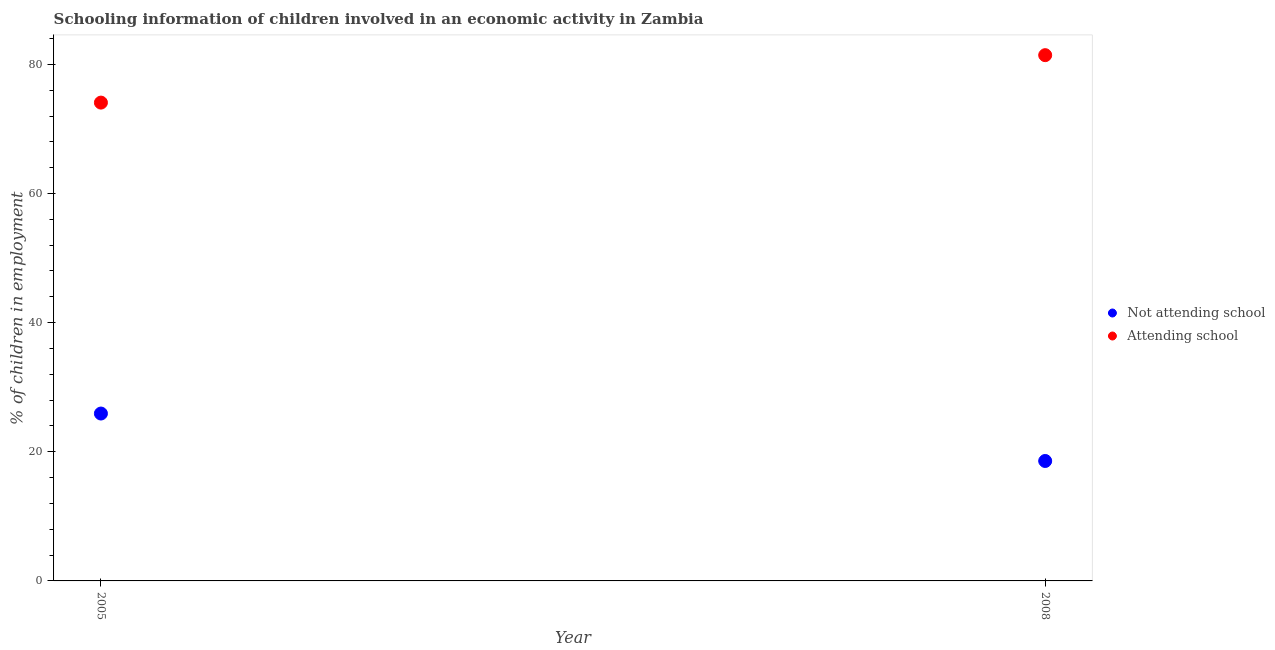Is the number of dotlines equal to the number of legend labels?
Your answer should be compact. Yes. What is the percentage of employed children who are attending school in 2008?
Provide a succinct answer. 81.42. Across all years, what is the maximum percentage of employed children who are not attending school?
Your response must be concise. 25.92. Across all years, what is the minimum percentage of employed children who are not attending school?
Make the answer very short. 18.58. In which year was the percentage of employed children who are not attending school maximum?
Your answer should be compact. 2005. In which year was the percentage of employed children who are not attending school minimum?
Ensure brevity in your answer.  2008. What is the total percentage of employed children who are not attending school in the graph?
Give a very brief answer. 44.5. What is the difference between the percentage of employed children who are not attending school in 2005 and that in 2008?
Make the answer very short. 7.35. What is the difference between the percentage of employed children who are attending school in 2005 and the percentage of employed children who are not attending school in 2008?
Offer a terse response. 55.5. What is the average percentage of employed children who are not attending school per year?
Your response must be concise. 22.25. In the year 2005, what is the difference between the percentage of employed children who are attending school and percentage of employed children who are not attending school?
Offer a terse response. 48.15. In how many years, is the percentage of employed children who are not attending school greater than 76 %?
Your response must be concise. 0. What is the ratio of the percentage of employed children who are attending school in 2005 to that in 2008?
Your response must be concise. 0.91. How many dotlines are there?
Your response must be concise. 2. Does the graph contain grids?
Offer a very short reply. No. Where does the legend appear in the graph?
Keep it short and to the point. Center right. How are the legend labels stacked?
Provide a short and direct response. Vertical. What is the title of the graph?
Make the answer very short. Schooling information of children involved in an economic activity in Zambia. What is the label or title of the X-axis?
Ensure brevity in your answer.  Year. What is the label or title of the Y-axis?
Ensure brevity in your answer.  % of children in employment. What is the % of children in employment of Not attending school in 2005?
Your answer should be very brief. 25.92. What is the % of children in employment of Attending school in 2005?
Make the answer very short. 74.08. What is the % of children in employment of Not attending school in 2008?
Offer a terse response. 18.58. What is the % of children in employment in Attending school in 2008?
Your answer should be compact. 81.42. Across all years, what is the maximum % of children in employment in Not attending school?
Keep it short and to the point. 25.92. Across all years, what is the maximum % of children in employment in Attending school?
Your response must be concise. 81.42. Across all years, what is the minimum % of children in employment in Not attending school?
Provide a succinct answer. 18.58. Across all years, what is the minimum % of children in employment of Attending school?
Offer a very short reply. 74.08. What is the total % of children in employment in Not attending school in the graph?
Give a very brief answer. 44.5. What is the total % of children in employment of Attending school in the graph?
Ensure brevity in your answer.  155.5. What is the difference between the % of children in employment in Not attending school in 2005 and that in 2008?
Your response must be concise. 7.35. What is the difference between the % of children in employment of Attending school in 2005 and that in 2008?
Keep it short and to the point. -7.35. What is the difference between the % of children in employment of Not attending school in 2005 and the % of children in employment of Attending school in 2008?
Ensure brevity in your answer.  -55.5. What is the average % of children in employment of Not attending school per year?
Ensure brevity in your answer.  22.25. What is the average % of children in employment of Attending school per year?
Make the answer very short. 77.75. In the year 2005, what is the difference between the % of children in employment of Not attending school and % of children in employment of Attending school?
Make the answer very short. -48.15. In the year 2008, what is the difference between the % of children in employment of Not attending school and % of children in employment of Attending school?
Your response must be concise. -62.85. What is the ratio of the % of children in employment in Not attending school in 2005 to that in 2008?
Offer a terse response. 1.4. What is the ratio of the % of children in employment in Attending school in 2005 to that in 2008?
Offer a very short reply. 0.91. What is the difference between the highest and the second highest % of children in employment of Not attending school?
Make the answer very short. 7.35. What is the difference between the highest and the second highest % of children in employment of Attending school?
Your answer should be very brief. 7.35. What is the difference between the highest and the lowest % of children in employment in Not attending school?
Your answer should be very brief. 7.35. What is the difference between the highest and the lowest % of children in employment in Attending school?
Ensure brevity in your answer.  7.35. 